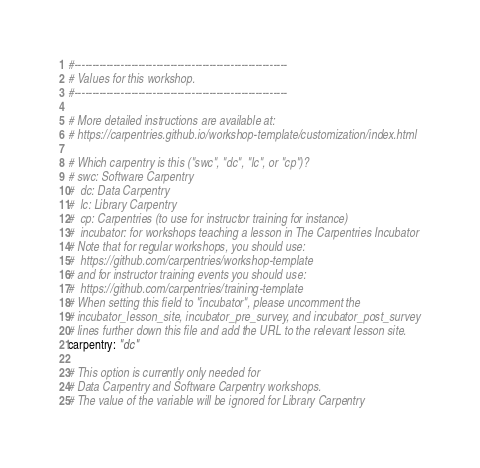Convert code to text. <code><loc_0><loc_0><loc_500><loc_500><_YAML_>#------------------------------------------------------------
# Values for this workshop.
#------------------------------------------------------------

# More detailed instructions are available at:
# https://carpentries.github.io/workshop-template/customization/index.html

# Which carpentry is this ("swc", "dc", "lc", or "cp")?
# swc: Software Carpentry
#  dc: Data Carpentry
#  lc: Library Carpentry
#  cp: Carpentries (to use for instructor training for instance)
#  incubator: for workshops teaching a lesson in The Carpentries Incubator
# Note that for regular workshops, you should use:
#  https://github.com/carpentries/workshop-template
# and for instructor training events you should use:
#  https://github.com/carpentries/training-template
# When setting this field to "incubator", please uncomment the
# incubator_lesson_site, incubator_pre_survey, and incubator_post_survey
# lines further down this file and add the URL to the relevant lesson site.
carpentry: "dc"

# This option is currently only needed for
# Data Carpentry and Software Carpentry workshops.
# The value of the variable will be ignored for Library Carpentry</code> 